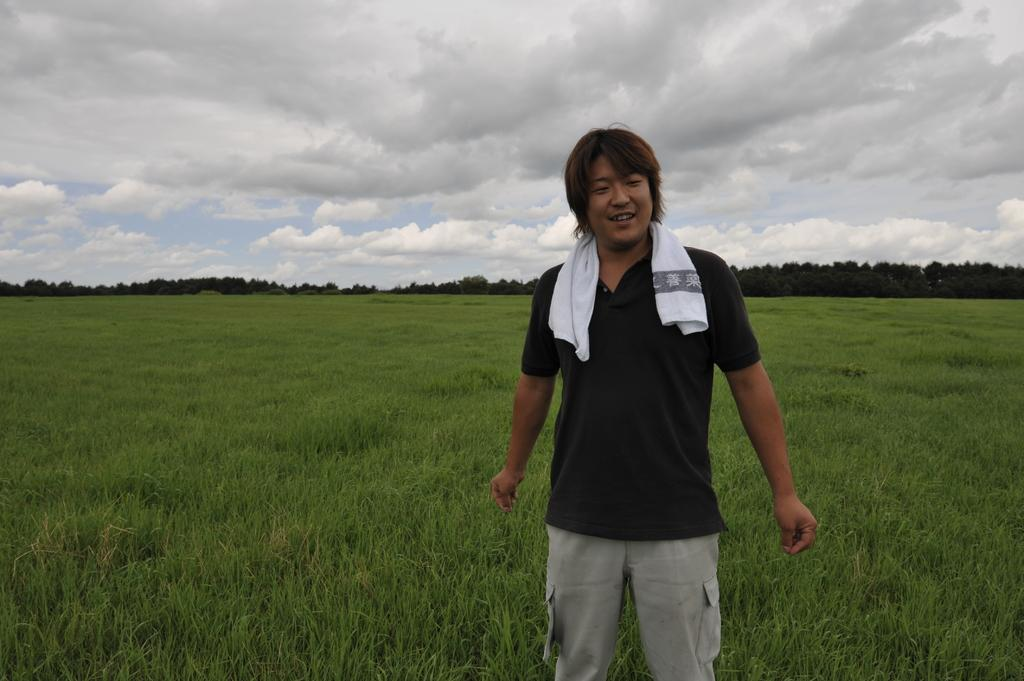Who or what is the main subject in the image? There is a person in the image. What type of natural environment is visible in the background? There is grass and trees in the background of the image. What else can be seen in the background of the image? There are other objects in the background of the image. What is visible at the top of the image? The sky is visible at the top of the image. How much money is in the person's account in the image? There is no information about the person's account or any financial details in the image. 